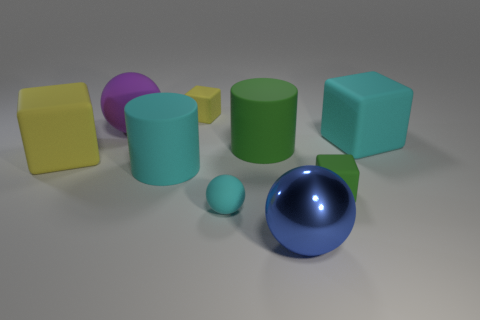Is the material of the green thing on the left side of the big metallic sphere the same as the cyan sphere?
Your response must be concise. Yes. What number of tiny objects are made of the same material as the large green object?
Ensure brevity in your answer.  3. Are there more cyan cubes that are on the left side of the tiny yellow rubber cube than large rubber cylinders?
Keep it short and to the point. No. There is a cylinder that is the same color as the tiny ball; what size is it?
Give a very brief answer. Large. Are there any tiny metal objects that have the same shape as the large blue metal object?
Provide a succinct answer. No. How many objects are either rubber things or purple spheres?
Ensure brevity in your answer.  8. How many rubber objects are on the left side of the small thing that is behind the cylinder on the right side of the small sphere?
Offer a very short reply. 3. There is another big thing that is the same shape as the big purple thing; what is its material?
Give a very brief answer. Metal. The tiny object that is in front of the small yellow rubber object and left of the blue ball is made of what material?
Offer a very short reply. Rubber. Are there fewer large matte balls that are behind the big yellow rubber block than tiny rubber balls on the left side of the blue object?
Make the answer very short. No. 